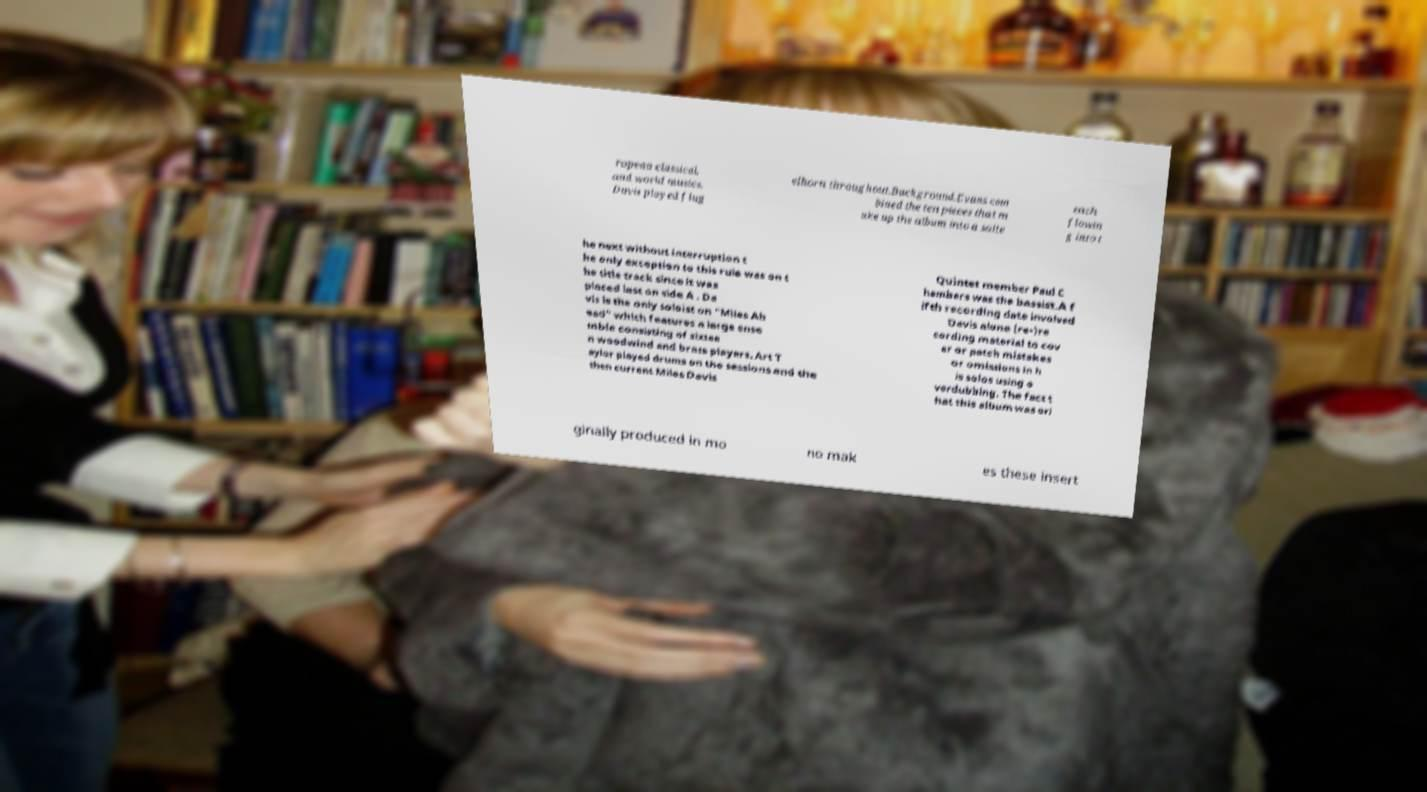Could you assist in decoding the text presented in this image and type it out clearly? ropean classical, and world musics. Davis played flug elhorn throughout.Background.Evans com bined the ten pieces that m ake up the album into a suite each flowin g into t he next without interruption t he only exception to this rule was on t he title track since it was placed last on side A . Da vis is the only soloist on "Miles Ah ead" which features a large ense mble consisting of sixtee n woodwind and brass players. Art T aylor played drums on the sessions and the then current Miles Davis Quintet member Paul C hambers was the bassist.A f ifth recording date involved Davis alone (re-)re cording material to cov er or patch mistakes or omissions in h is solos using o verdubbing. The fact t hat this album was ori ginally produced in mo no mak es these insert 